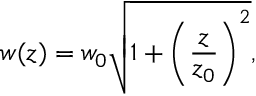Convert formula to latex. <formula><loc_0><loc_0><loc_500><loc_500>w ( z ) = w _ { 0 } \sqrt { 1 + \left ( \frac { z } { z _ { 0 } } \right ) ^ { 2 } } ,</formula> 